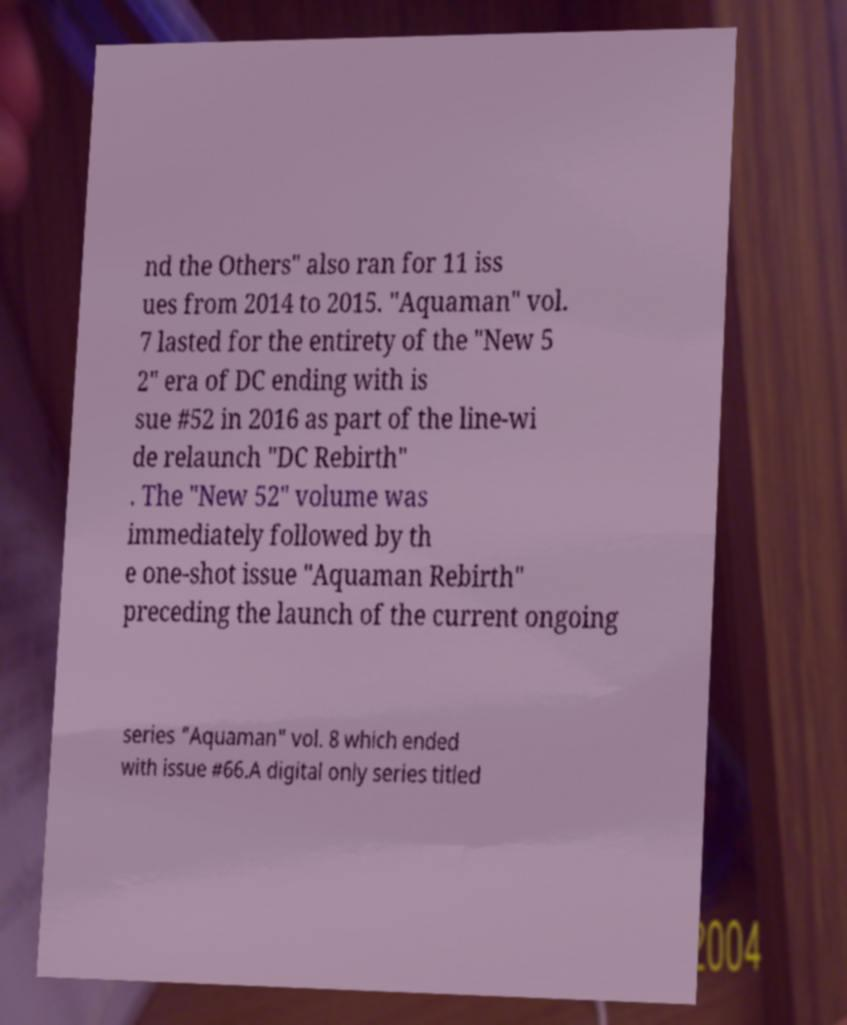Please identify and transcribe the text found in this image. nd the Others" also ran for 11 iss ues from 2014 to 2015. "Aquaman" vol. 7 lasted for the entirety of the "New 5 2" era of DC ending with is sue #52 in 2016 as part of the line-wi de relaunch "DC Rebirth" . The "New 52" volume was immediately followed by th e one-shot issue "Aquaman Rebirth" preceding the launch of the current ongoing series "Aquaman" vol. 8 which ended with issue #66.A digital only series titled 